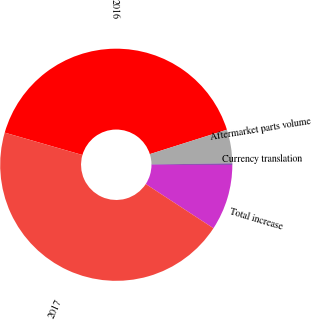<chart> <loc_0><loc_0><loc_500><loc_500><pie_chart><fcel>2016<fcel>Aftermarket parts volume<fcel>Currency translation<fcel>Total increase<fcel>2017<nl><fcel>40.65%<fcel>4.7%<fcel>0.19%<fcel>9.2%<fcel>45.25%<nl></chart> 